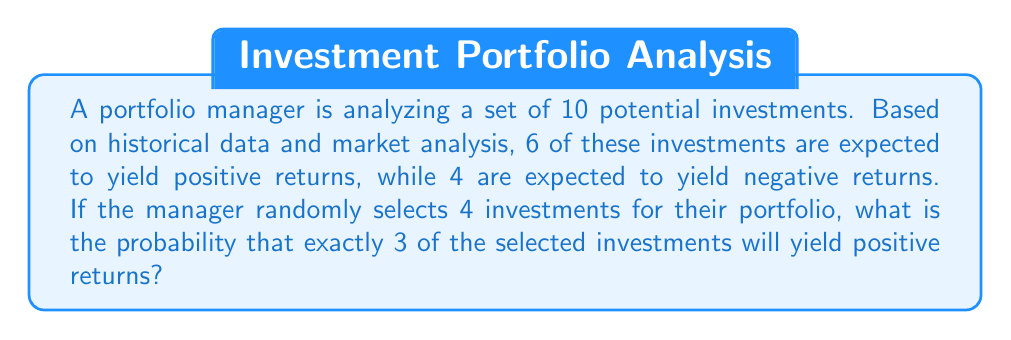Solve this math problem. To solve this problem, we'll use combinatorics, specifically the hypergeometric distribution. Here's the step-by-step approach:

1) We have:
   - Total number of investments: $N = 10$
   - Number of investments with positive returns: $K = 6$
   - Number of investments selected: $n = 4$
   - Number of positive returns we want in our selection: $k = 3$

2) The probability of selecting exactly 3 positive returns out of 4 selections is given by:

   $$P(X = 3) = \frac{\binom{K}{k} \binom{N-K}{n-k}}{\binom{N}{n}}$$

3) Let's calculate each combination:

   $$\binom{K}{k} = \binom{6}{3} = \frac{6!}{3!(6-3)!} = \frac{6 \cdot 5 \cdot 4}{3 \cdot 2 \cdot 1} = 20$$

   $$\binom{N-K}{n-k} = \binom{4}{1} = \frac{4!}{1!(4-1)!} = 4$$

   $$\binom{N}{n} = \binom{10}{4} = \frac{10!}{4!(10-4)!} = \frac{10 \cdot 9 \cdot 8 \cdot 7}{4 \cdot 3 \cdot 2 \cdot 1} = 210$$

4) Now, let's substitute these values into our probability formula:

   $$P(X = 3) = \frac{20 \cdot 4}{210} = \frac{80}{210} = \frac{8}{21} \approx 0.3810$$

Therefore, the probability of selecting exactly 3 investments with positive returns out of 4 randomly selected investments is $\frac{8}{21}$ or approximately 38.10%.
Answer: $\frac{8}{21}$ or approximately 0.3810 (38.10%) 